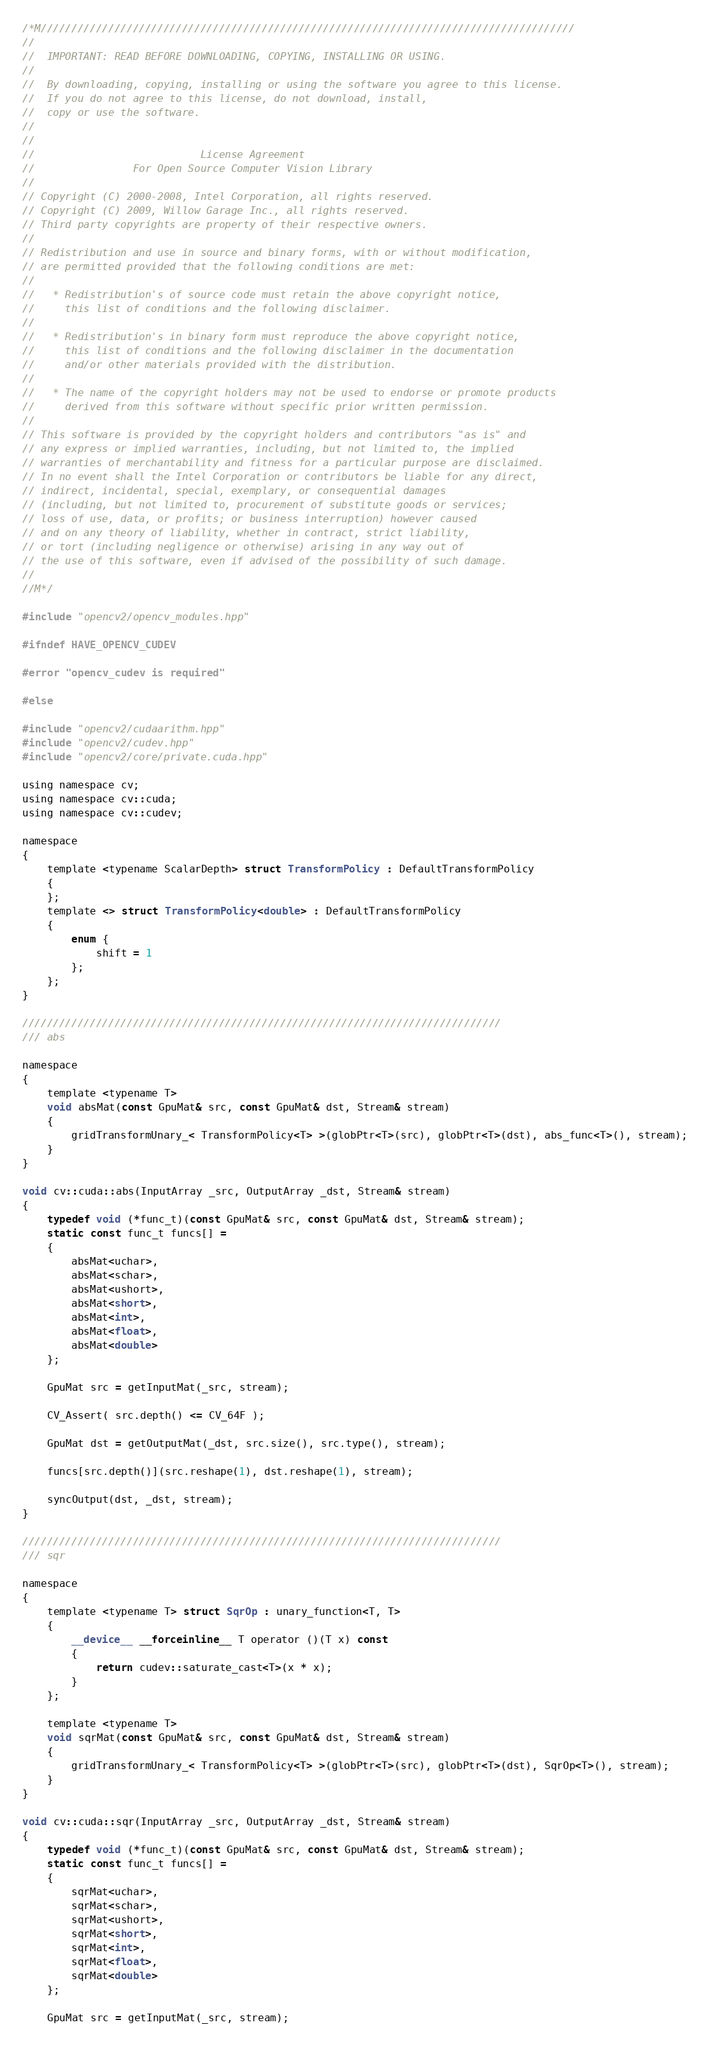<code> <loc_0><loc_0><loc_500><loc_500><_Cuda_>/*M///////////////////////////////////////////////////////////////////////////////////////
//
//  IMPORTANT: READ BEFORE DOWNLOADING, COPYING, INSTALLING OR USING.
//
//  By downloading, copying, installing or using the software you agree to this license.
//  If you do not agree to this license, do not download, install,
//  copy or use the software.
//
//
//                           License Agreement
//                For Open Source Computer Vision Library
//
// Copyright (C) 2000-2008, Intel Corporation, all rights reserved.
// Copyright (C) 2009, Willow Garage Inc., all rights reserved.
// Third party copyrights are property of their respective owners.
//
// Redistribution and use in source and binary forms, with or without modification,
// are permitted provided that the following conditions are met:
//
//   * Redistribution's of source code must retain the above copyright notice,
//     this list of conditions and the following disclaimer.
//
//   * Redistribution's in binary form must reproduce the above copyright notice,
//     this list of conditions and the following disclaimer in the documentation
//     and/or other materials provided with the distribution.
//
//   * The name of the copyright holders may not be used to endorse or promote products
//     derived from this software without specific prior written permission.
//
// This software is provided by the copyright holders and contributors "as is" and
// any express or implied warranties, including, but not limited to, the implied
// warranties of merchantability and fitness for a particular purpose are disclaimed.
// In no event shall the Intel Corporation or contributors be liable for any direct,
// indirect, incidental, special, exemplary, or consequential damages
// (including, but not limited to, procurement of substitute goods or services;
// loss of use, data, or profits; or business interruption) however caused
// and on any theory of liability, whether in contract, strict liability,
// or tort (including negligence or otherwise) arising in any way out of
// the use of this software, even if advised of the possibility of such damage.
//
//M*/

#include "opencv2/opencv_modules.hpp"

#ifndef HAVE_OPENCV_CUDEV

#error "opencv_cudev is required"

#else

#include "opencv2/cudaarithm.hpp"
#include "opencv2/cudev.hpp"
#include "opencv2/core/private.cuda.hpp"

using namespace cv;
using namespace cv::cuda;
using namespace cv::cudev;

namespace
{
    template <typename ScalarDepth> struct TransformPolicy : DefaultTransformPolicy
    {
    };
    template <> struct TransformPolicy<double> : DefaultTransformPolicy
    {
        enum {
            shift = 1
        };
    };
}

//////////////////////////////////////////////////////////////////////////////
/// abs

namespace
{
    template <typename T>
    void absMat(const GpuMat& src, const GpuMat& dst, Stream& stream)
    {
        gridTransformUnary_< TransformPolicy<T> >(globPtr<T>(src), globPtr<T>(dst), abs_func<T>(), stream);
    }
}

void cv::cuda::abs(InputArray _src, OutputArray _dst, Stream& stream)
{
    typedef void (*func_t)(const GpuMat& src, const GpuMat& dst, Stream& stream);
    static const func_t funcs[] =
    {
        absMat<uchar>,
        absMat<schar>,
        absMat<ushort>,
        absMat<short>,
        absMat<int>,
        absMat<float>,
        absMat<double>
    };

    GpuMat src = getInputMat(_src, stream);

    CV_Assert( src.depth() <= CV_64F );

    GpuMat dst = getOutputMat(_dst, src.size(), src.type(), stream);

    funcs[src.depth()](src.reshape(1), dst.reshape(1), stream);

    syncOutput(dst, _dst, stream);
}

//////////////////////////////////////////////////////////////////////////////
/// sqr

namespace
{
    template <typename T> struct SqrOp : unary_function<T, T>
    {
        __device__ __forceinline__ T operator ()(T x) const
        {
            return cudev::saturate_cast<T>(x * x);
        }
    };

    template <typename T>
    void sqrMat(const GpuMat& src, const GpuMat& dst, Stream& stream)
    {
        gridTransformUnary_< TransformPolicy<T> >(globPtr<T>(src), globPtr<T>(dst), SqrOp<T>(), stream);
    }
}

void cv::cuda::sqr(InputArray _src, OutputArray _dst, Stream& stream)
{
    typedef void (*func_t)(const GpuMat& src, const GpuMat& dst, Stream& stream);
    static const func_t funcs[] =
    {
        sqrMat<uchar>,
        sqrMat<schar>,
        sqrMat<ushort>,
        sqrMat<short>,
        sqrMat<int>,
        sqrMat<float>,
        sqrMat<double>
    };

    GpuMat src = getInputMat(_src, stream);
</code> 